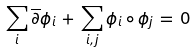<formula> <loc_0><loc_0><loc_500><loc_500>\sum _ { i } \overline { \partial } \phi _ { i } \, + \, \sum _ { i , j } \phi _ { i } \circ \phi _ { j } \, = \, 0</formula> 